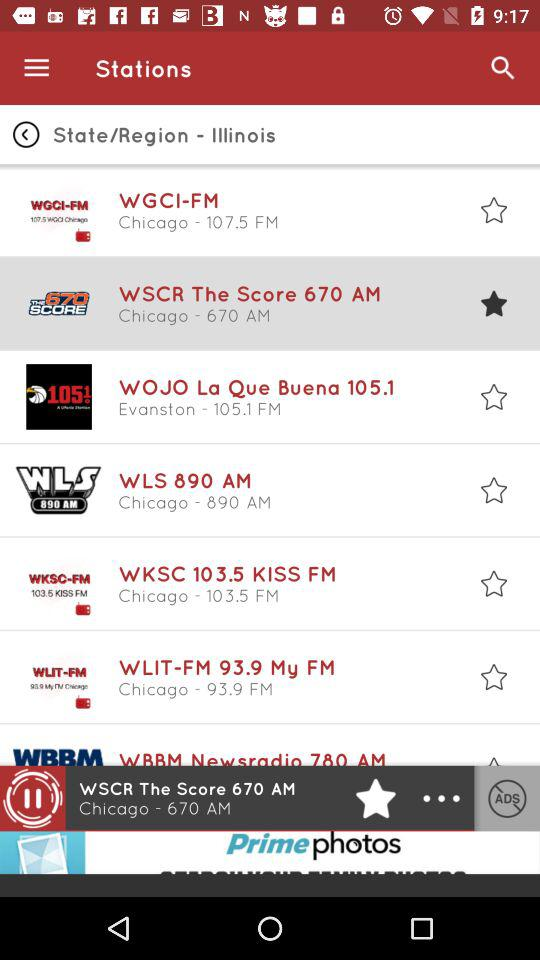Which state or region is displayed on the screen? The displayed state or region is Illinois. 